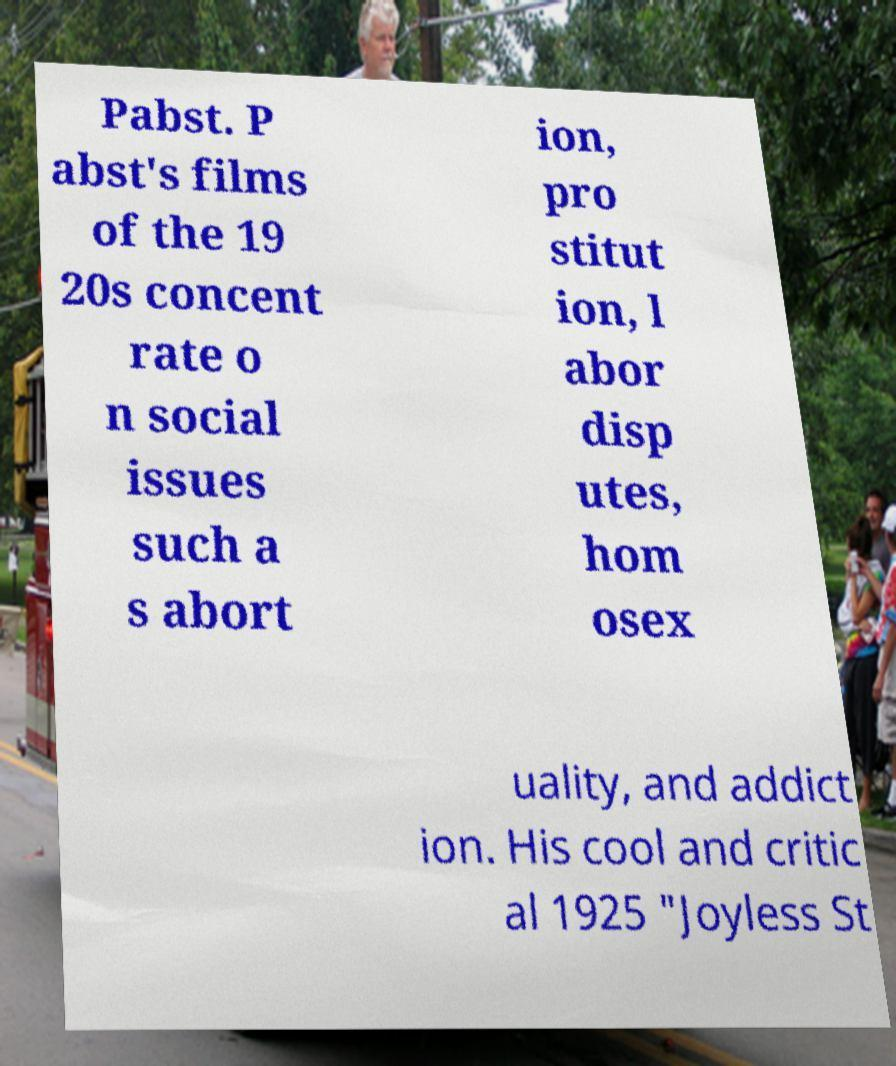Could you assist in decoding the text presented in this image and type it out clearly? Pabst. P abst's films of the 19 20s concent rate o n social issues such a s abort ion, pro stitut ion, l abor disp utes, hom osex uality, and addict ion. His cool and critic al 1925 "Joyless St 